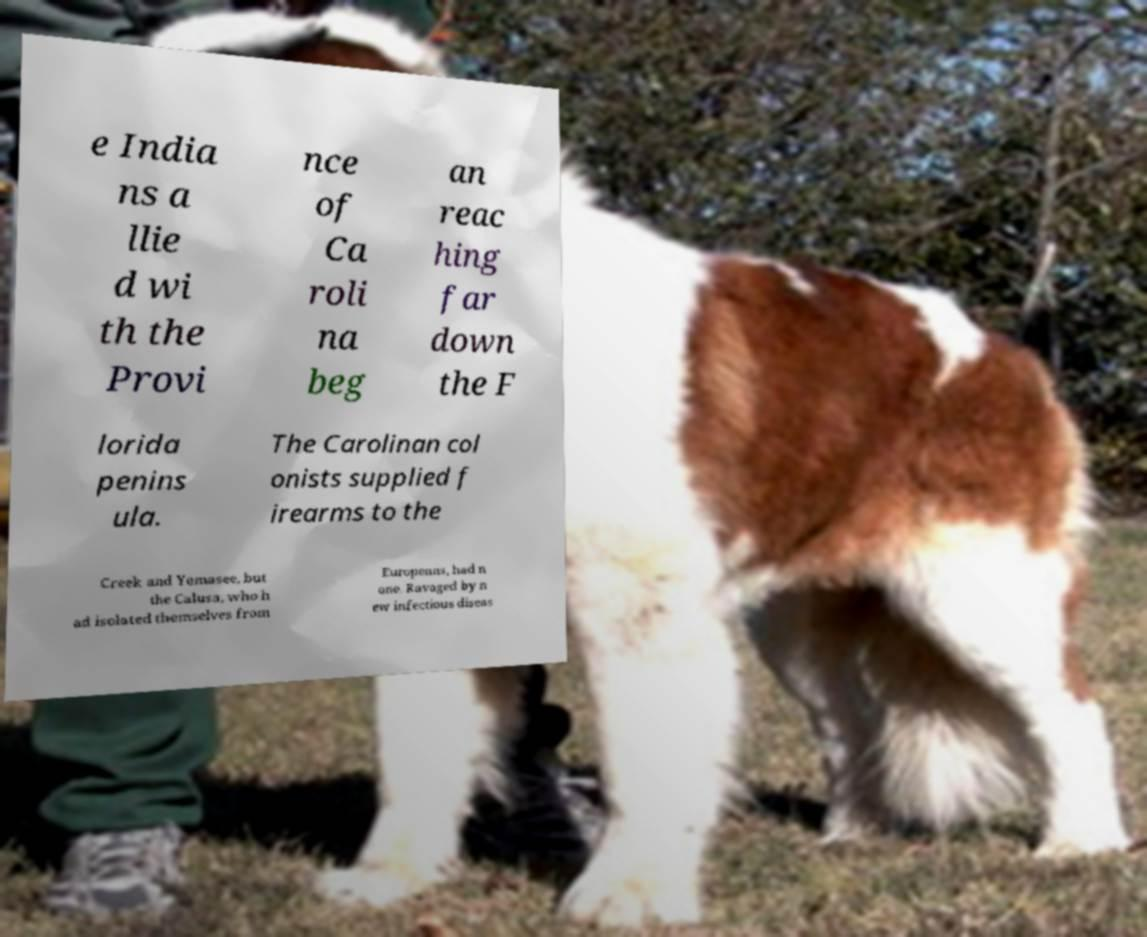I need the written content from this picture converted into text. Can you do that? e India ns a llie d wi th the Provi nce of Ca roli na beg an reac hing far down the F lorida penins ula. The Carolinan col onists supplied f irearms to the Creek and Yemasee, but the Calusa, who h ad isolated themselves from Europeans, had n one. Ravaged by n ew infectious diseas 